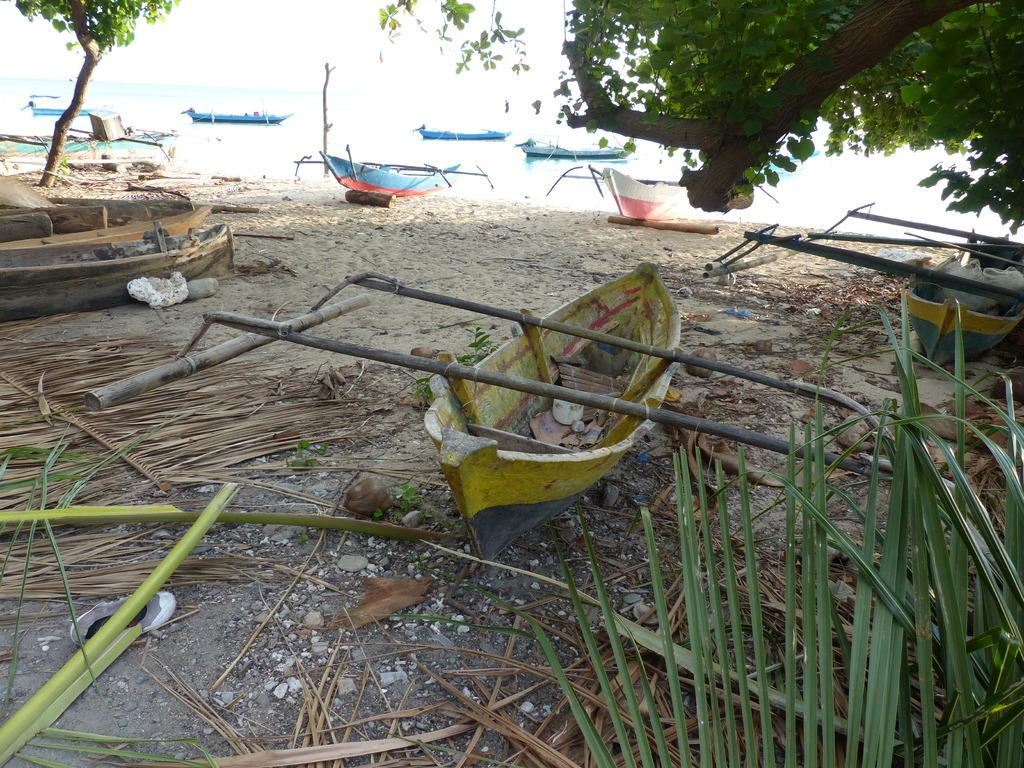What type of surface is present in the image? The image contains a sand surface. What can be found on the sand surface? There are dried plants, leaves, boats, and stones on the sand surface. Can you describe the water visible in the image? There is water visible behind the sand surface, and there are boats in the water. What type of suit can be seen hanging from the dried plants in the image? There is no suit present in the image; it features a sand surface with dried plants, leaves, boats, and stones. Can you describe the feathers on the boats in the image? There are no feathers mentioned or visible on the boats in the image. 